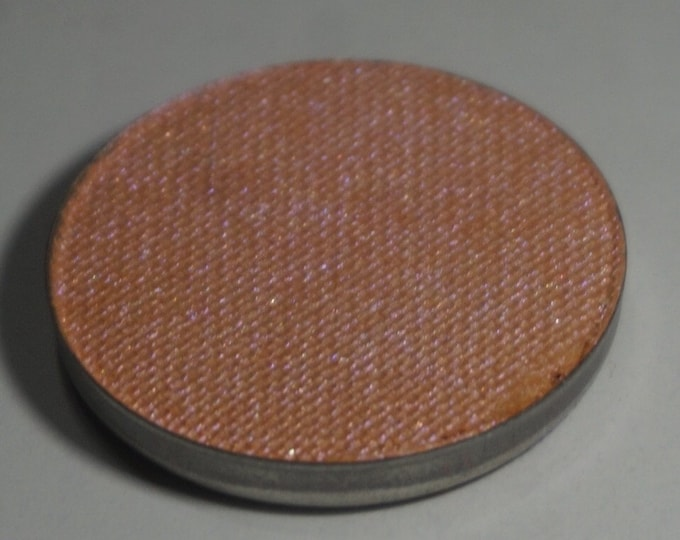Can you envision a futuristic scenario where this disc plays a crucial role? In a futuristic scenario, this disc might play an integral role in advanced acoustic engineering, perhaps in a smart home system where it functions as a multimodal sensor. Integrated with nanotechnology, it could act both as a speaker cover and a sensor array that detects sound, temperature, and air quality, providing real-time feedback to a central AI system. This AI could utilize the data to optimize the environment in a home or office for comfort, health, and efficiency, adjusting cooling systems, purifiers, and ambient sounds accordingly. Describe a sci-fi world that heavily relies on devices incorporating these discs. Imagine a sci-fi world where every surface and object can communicate and adapt to human needs. In this world, buildings are constructed using smart materials, including discs like the one pictured, embedded everywhere from walls to furniture. These discs serve multiple functions: they can emit soothing sounds, charge devices wirelessly, monitor environmental conditions, and even change colors to suit different moods or settings. People live in seamless harmony with this integrated ecosystem; their homes automatically adjust lighting, temperature, and background music based on biometric data collected by these discs. The discs are solar-powered, contributing to an entirely sustainable living environment. Their multifunctional nature reduces the need for separate gadgets, creating a clutter-free and efficient space. These advanced materials are a testimony to the blend of high functionality and aesthetic design, crucial for living in this futuristic, hyper-connected society. 